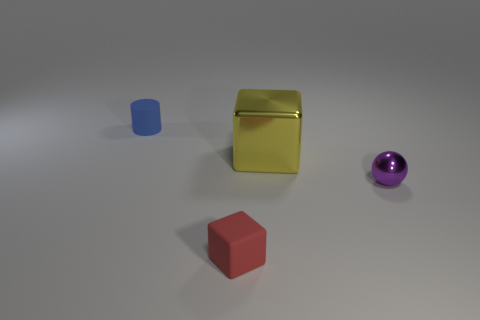Add 1 small matte cylinders. How many objects exist? 5 Subtract all red blocks. How many blocks are left? 1 Subtract 0 green cubes. How many objects are left? 4 Subtract all cylinders. How many objects are left? 3 Subtract 1 blocks. How many blocks are left? 1 Subtract all red cylinders. Subtract all green cubes. How many cylinders are left? 1 Subtract all gray balls. How many gray cylinders are left? 0 Subtract all big cyan metallic things. Subtract all shiny things. How many objects are left? 2 Add 1 small matte cylinders. How many small matte cylinders are left? 2 Add 1 big yellow matte cylinders. How many big yellow matte cylinders exist? 1 